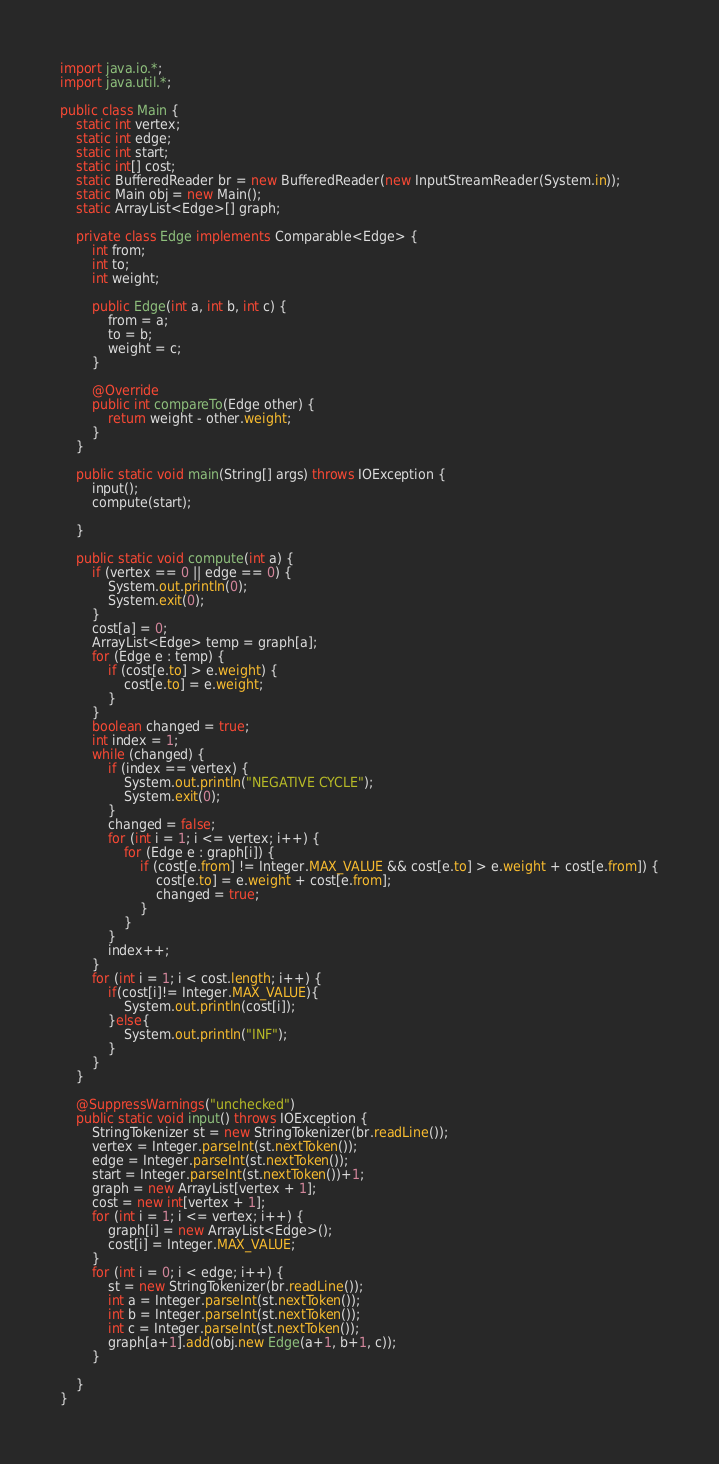<code> <loc_0><loc_0><loc_500><loc_500><_Java_>import java.io.*;
import java.util.*;

public class Main {
	static int vertex;
	static int edge;
	static int start;
	static int[] cost;
	static BufferedReader br = new BufferedReader(new InputStreamReader(System.in));
	static Main obj = new Main();
	static ArrayList<Edge>[] graph;

	private class Edge implements Comparable<Edge> {
		int from;
		int to;
		int weight;

		public Edge(int a, int b, int c) {
			from = a;
			to = b;
			weight = c;
		}

		@Override
		public int compareTo(Edge other) {
			return weight - other.weight;
		}
	}

	public static void main(String[] args) throws IOException {
		input();
		compute(start);

	}

	public static void compute(int a) {
		if (vertex == 0 || edge == 0) {
			System.out.println(0);
			System.exit(0);
		}
		cost[a] = 0;
		ArrayList<Edge> temp = graph[a];
		for (Edge e : temp) {
			if (cost[e.to] > e.weight) {
				cost[e.to] = e.weight;
			}
		}
		boolean changed = true;
		int index = 1;
		while (changed) {
			if (index == vertex) {
				System.out.println("NEGATIVE CYCLE");
				System.exit(0);
			}
			changed = false;
			for (int i = 1; i <= vertex; i++) {
				for (Edge e : graph[i]) {
					if (cost[e.from] != Integer.MAX_VALUE && cost[e.to] > e.weight + cost[e.from]) {
						cost[e.to] = e.weight + cost[e.from];
						changed = true;
					}
				}
			}
			index++;
		}
		for (int i = 1; i < cost.length; i++) {
			if(cost[i]!= Integer.MAX_VALUE){
				System.out.println(cost[i]);
			}else{
				System.out.println("INF");
			}
		}
	}

	@SuppressWarnings("unchecked")
	public static void input() throws IOException {
		StringTokenizer st = new StringTokenizer(br.readLine());
		vertex = Integer.parseInt(st.nextToken());
		edge = Integer.parseInt(st.nextToken());
		start = Integer.parseInt(st.nextToken())+1;
		graph = new ArrayList[vertex + 1];
		cost = new int[vertex + 1];
		for (int i = 1; i <= vertex; i++) {
			graph[i] = new ArrayList<Edge>();
			cost[i] = Integer.MAX_VALUE;
		}
		for (int i = 0; i < edge; i++) {
			st = new StringTokenizer(br.readLine());
			int a = Integer.parseInt(st.nextToken());
			int b = Integer.parseInt(st.nextToken());
			int c = Integer.parseInt(st.nextToken());
			graph[a+1].add(obj.new Edge(a+1, b+1, c));
		}

	}
}</code> 